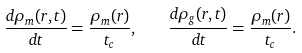<formula> <loc_0><loc_0><loc_500><loc_500>\frac { d \rho _ { m } ( r , t ) } { d t } = \frac { \rho _ { m } ( r ) } { t _ { c } } , \quad \frac { d \rho _ { g } ( r , t ) } { d t } = \frac { \rho _ { m } ( r ) } { t _ { c } } .</formula> 